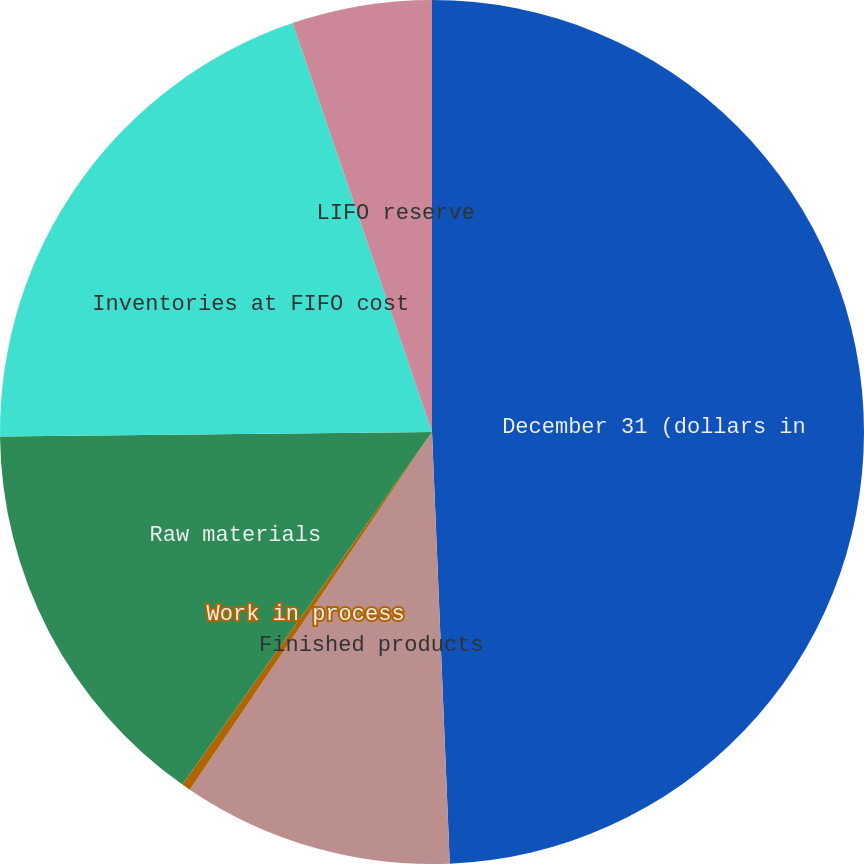Convert chart. <chart><loc_0><loc_0><loc_500><loc_500><pie_chart><fcel>December 31 (dollars in<fcel>Finished products<fcel>Work in process<fcel>Raw materials<fcel>Inventories at FIFO cost<fcel>LIFO reserve<nl><fcel>49.34%<fcel>10.13%<fcel>0.33%<fcel>15.03%<fcel>19.93%<fcel>5.23%<nl></chart> 